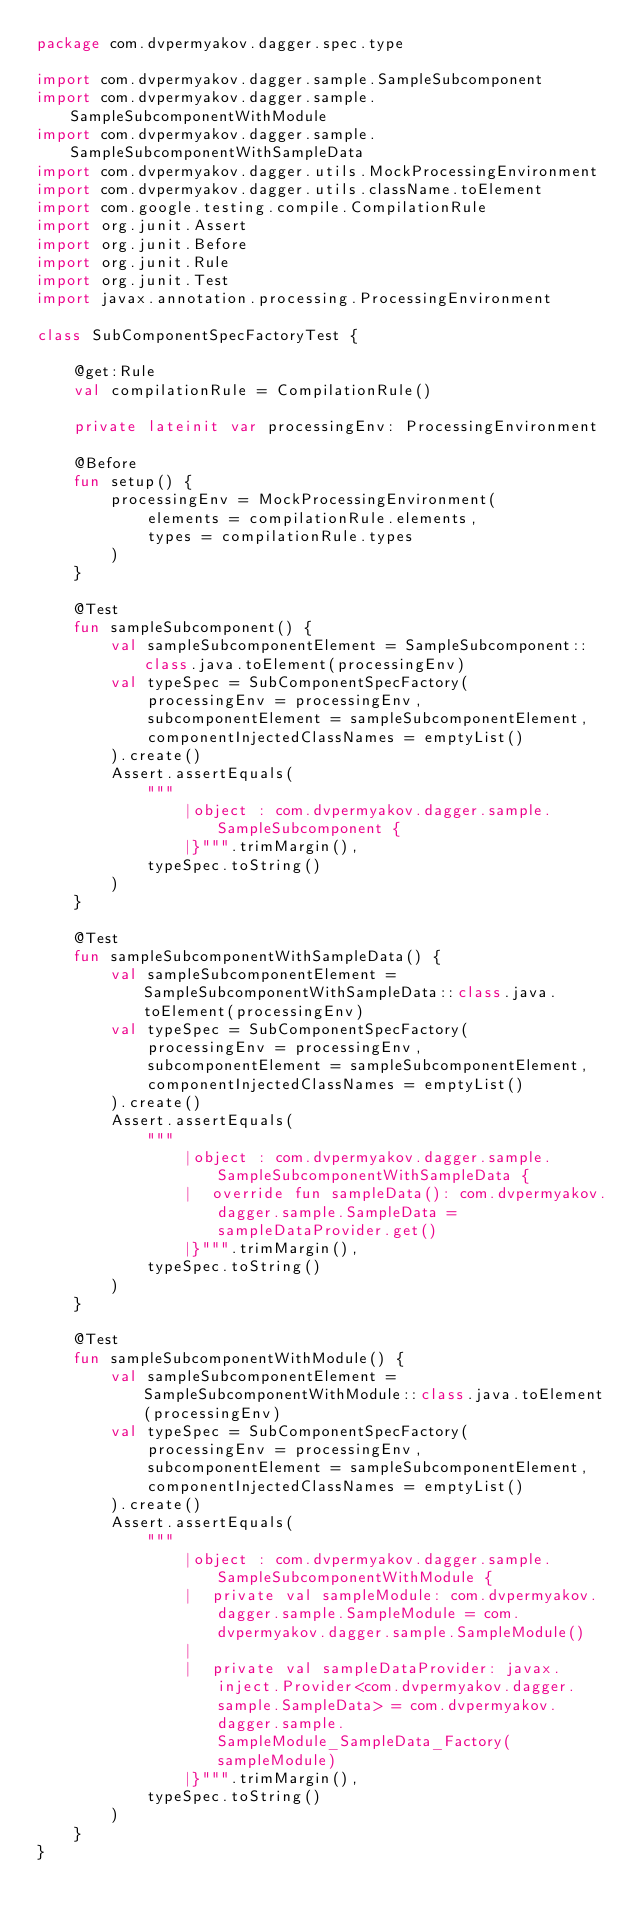<code> <loc_0><loc_0><loc_500><loc_500><_Kotlin_>package com.dvpermyakov.dagger.spec.type

import com.dvpermyakov.dagger.sample.SampleSubcomponent
import com.dvpermyakov.dagger.sample.SampleSubcomponentWithModule
import com.dvpermyakov.dagger.sample.SampleSubcomponentWithSampleData
import com.dvpermyakov.dagger.utils.MockProcessingEnvironment
import com.dvpermyakov.dagger.utils.className.toElement
import com.google.testing.compile.CompilationRule
import org.junit.Assert
import org.junit.Before
import org.junit.Rule
import org.junit.Test
import javax.annotation.processing.ProcessingEnvironment

class SubComponentSpecFactoryTest {

    @get:Rule
    val compilationRule = CompilationRule()

    private lateinit var processingEnv: ProcessingEnvironment

    @Before
    fun setup() {
        processingEnv = MockProcessingEnvironment(
            elements = compilationRule.elements,
            types = compilationRule.types
        )
    }

    @Test
    fun sampleSubcomponent() {
        val sampleSubcomponentElement = SampleSubcomponent::class.java.toElement(processingEnv)
        val typeSpec = SubComponentSpecFactory(
            processingEnv = processingEnv,
            subcomponentElement = sampleSubcomponentElement,
            componentInjectedClassNames = emptyList()
        ).create()
        Assert.assertEquals(
            """
                |object : com.dvpermyakov.dagger.sample.SampleSubcomponent {
                |}""".trimMargin(),
            typeSpec.toString()
        )
    }

    @Test
    fun sampleSubcomponentWithSampleData() {
        val sampleSubcomponentElement = SampleSubcomponentWithSampleData::class.java.toElement(processingEnv)
        val typeSpec = SubComponentSpecFactory(
            processingEnv = processingEnv,
            subcomponentElement = sampleSubcomponentElement,
            componentInjectedClassNames = emptyList()
        ).create()
        Assert.assertEquals(
            """
                |object : com.dvpermyakov.dagger.sample.SampleSubcomponentWithSampleData {
                |  override fun sampleData(): com.dvpermyakov.dagger.sample.SampleData = sampleDataProvider.get()
                |}""".trimMargin(),
            typeSpec.toString()
        )
    }

    @Test
    fun sampleSubcomponentWithModule() {
        val sampleSubcomponentElement = SampleSubcomponentWithModule::class.java.toElement(processingEnv)
        val typeSpec = SubComponentSpecFactory(
            processingEnv = processingEnv,
            subcomponentElement = sampleSubcomponentElement,
            componentInjectedClassNames = emptyList()
        ).create()
        Assert.assertEquals(
            """
                |object : com.dvpermyakov.dagger.sample.SampleSubcomponentWithModule {
                |  private val sampleModule: com.dvpermyakov.dagger.sample.SampleModule = com.dvpermyakov.dagger.sample.SampleModule()
                |
                |  private val sampleDataProvider: javax.inject.Provider<com.dvpermyakov.dagger.sample.SampleData> = com.dvpermyakov.dagger.sample.SampleModule_SampleData_Factory(sampleModule)
                |}""".trimMargin(),
            typeSpec.toString()
        )
    }
}</code> 